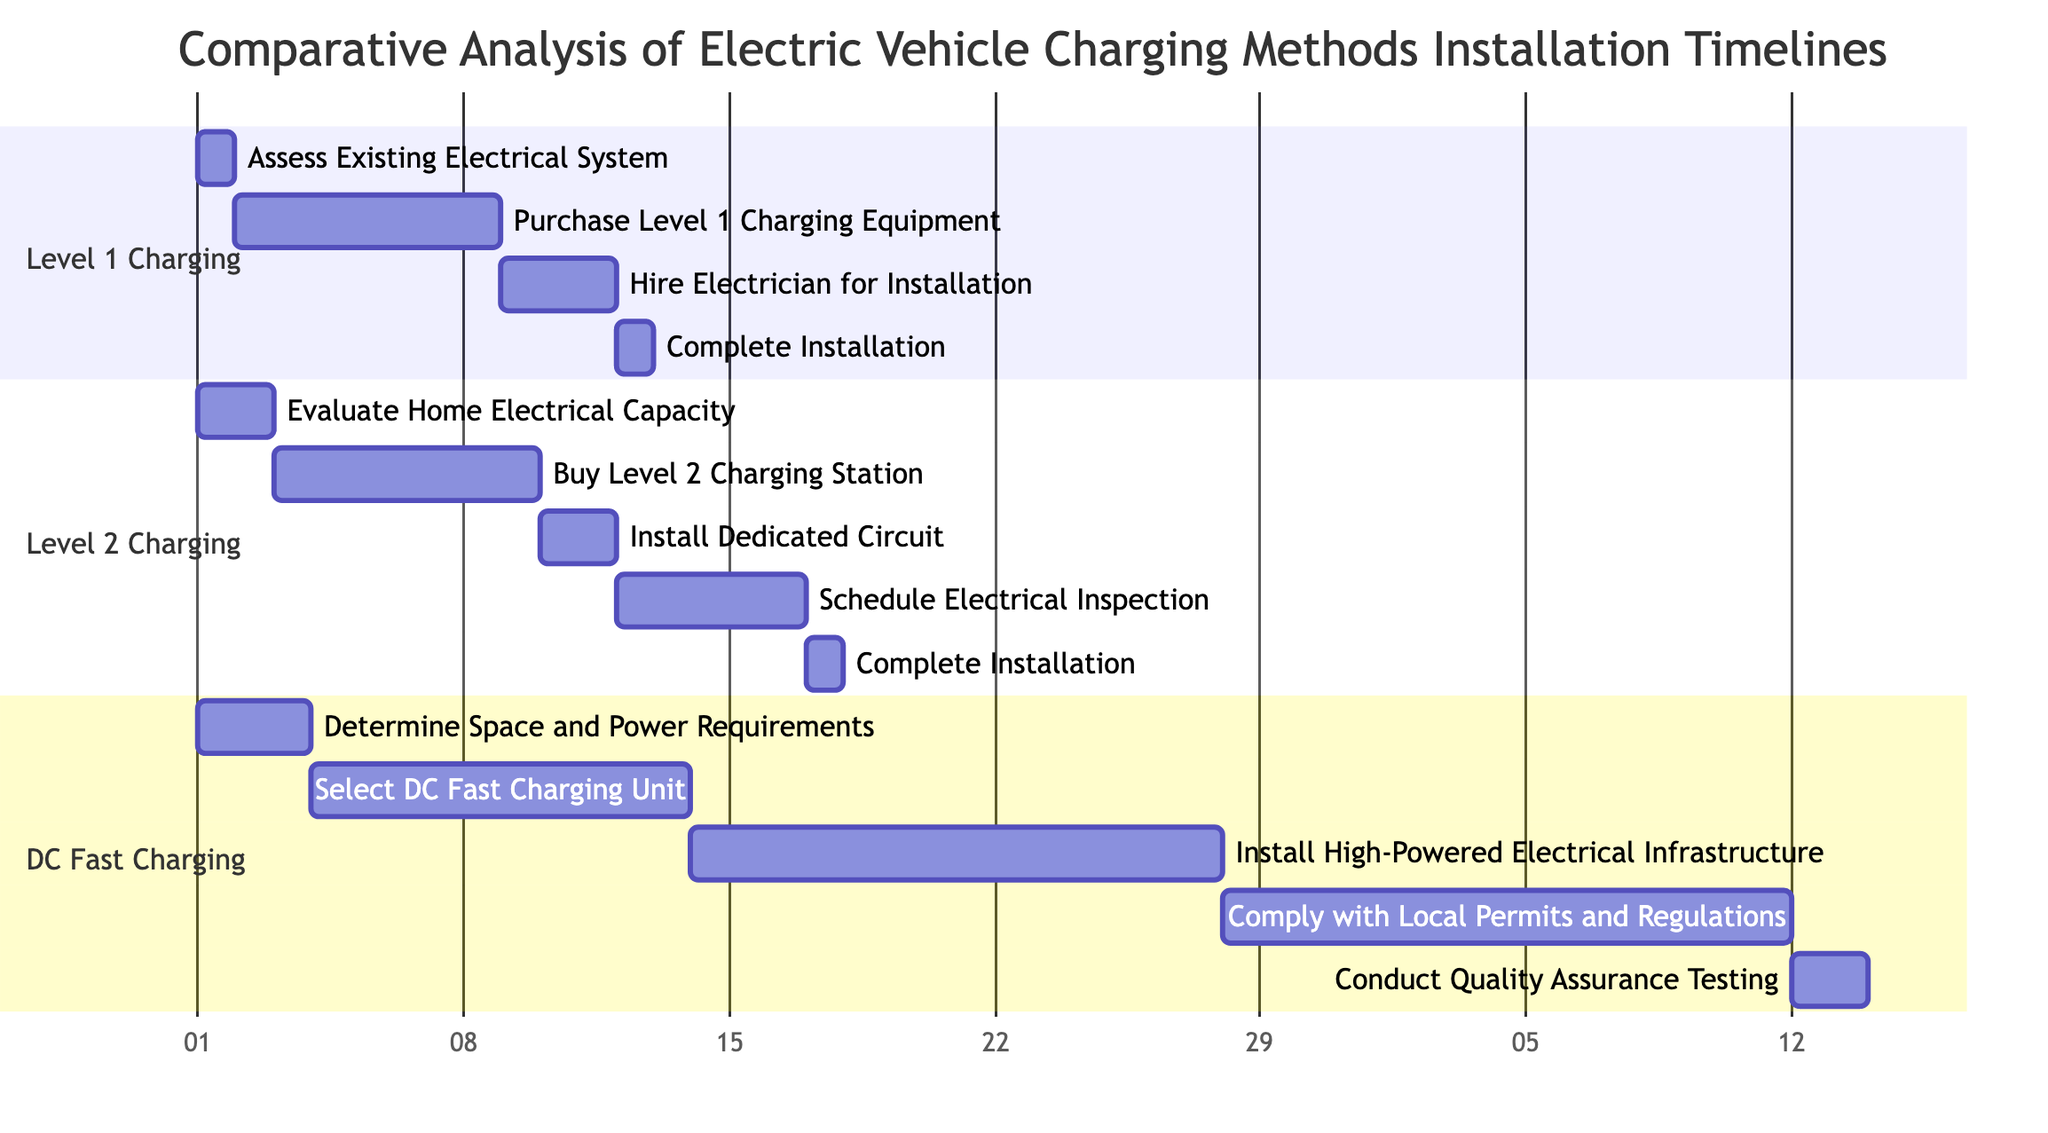What is the total duration of Level 1 Charging installation? The total duration for Level 1 Charging installation is calculated by summing the duration of all the steps. The steps are: 1 day for "Assess Existing Electrical System," 7 days for "Purchase Level 1 Charging Equipment," 3 days for "Hire Electrician for Installation," and 1 day for "Complete Installation." Adding these together gives 1 + 7 + 3 + 1 = 12 days.
Answer: 12 days How many steps are involved in Level 2 Charging installation? The installation of Level 2 Charging involves five distinct steps listed in the diagram. These steps are: "Evaluate Home Electrical Capacity," "Buy Level 2 Charging Station," "Install Dedicated Circuit," "Schedule Electrical Inspection," and "Complete Installation." Thus, there are 5 steps in total.
Answer: 5 steps Which charging method has the longest total installation duration? To determine which method has the longest installation duration, we compare the total duration of all methods: Level 1 Charging is 12 days, Level 2 Charging is 17 days, and DC Fast Charging is 44 days. Comparing these values, DC Fast Charging has the longest duration.
Answer: DC Fast Charging What step follows the "Select DC Fast Charging Unit"? Looking at the steps for DC Fast Charging, after "Select DC Fast Charging Unit," the next step is "Install High-Powered Electrical Infrastructure." This decision is based on the sequential order of the tasks.
Answer: Install High-Powered Electrical Infrastructure How many days does it take to "Complete Installation" for Level 2 Charging? In the timeline for Level 2 Charging, "Complete Installation" takes 1 day according to the corresponding bar in the diagram. This detail is explicitly mentioned in the breakdown of steps.
Answer: 1 day Which step in DC Fast Charging has the longest duration? Among the steps for DC Fast Charging, "Comply with Local Permits and Regulations" takes the longest duration of 15 days. This can be determined by comparing the durations of all steps in this section.
Answer: Comply with Local Permits and Regulations What is the total duration of installing Level 2 Charging and Level 1 Charging combined? To find the total duration for both Level 2 Charging and Level 1 Charging, we add their total durations: Level 2 Charging is 17 days and Level 1 Charging is 12 days. Thus, the total is 17 + 12 = 29 days.
Answer: 29 days What is the earliest start date for any charging method installation? All charging methods start their installation on January 1, 2023, as indicated by the start dates of the initial steps shown in the diagram.
Answer: January 1, 2023 What is the last step in Level 1 Charging? The last step in the installation timeline for Level 1 Charging is "Complete Installation." This is shown clearly at the end of the sequence for this method.
Answer: Complete Installation 